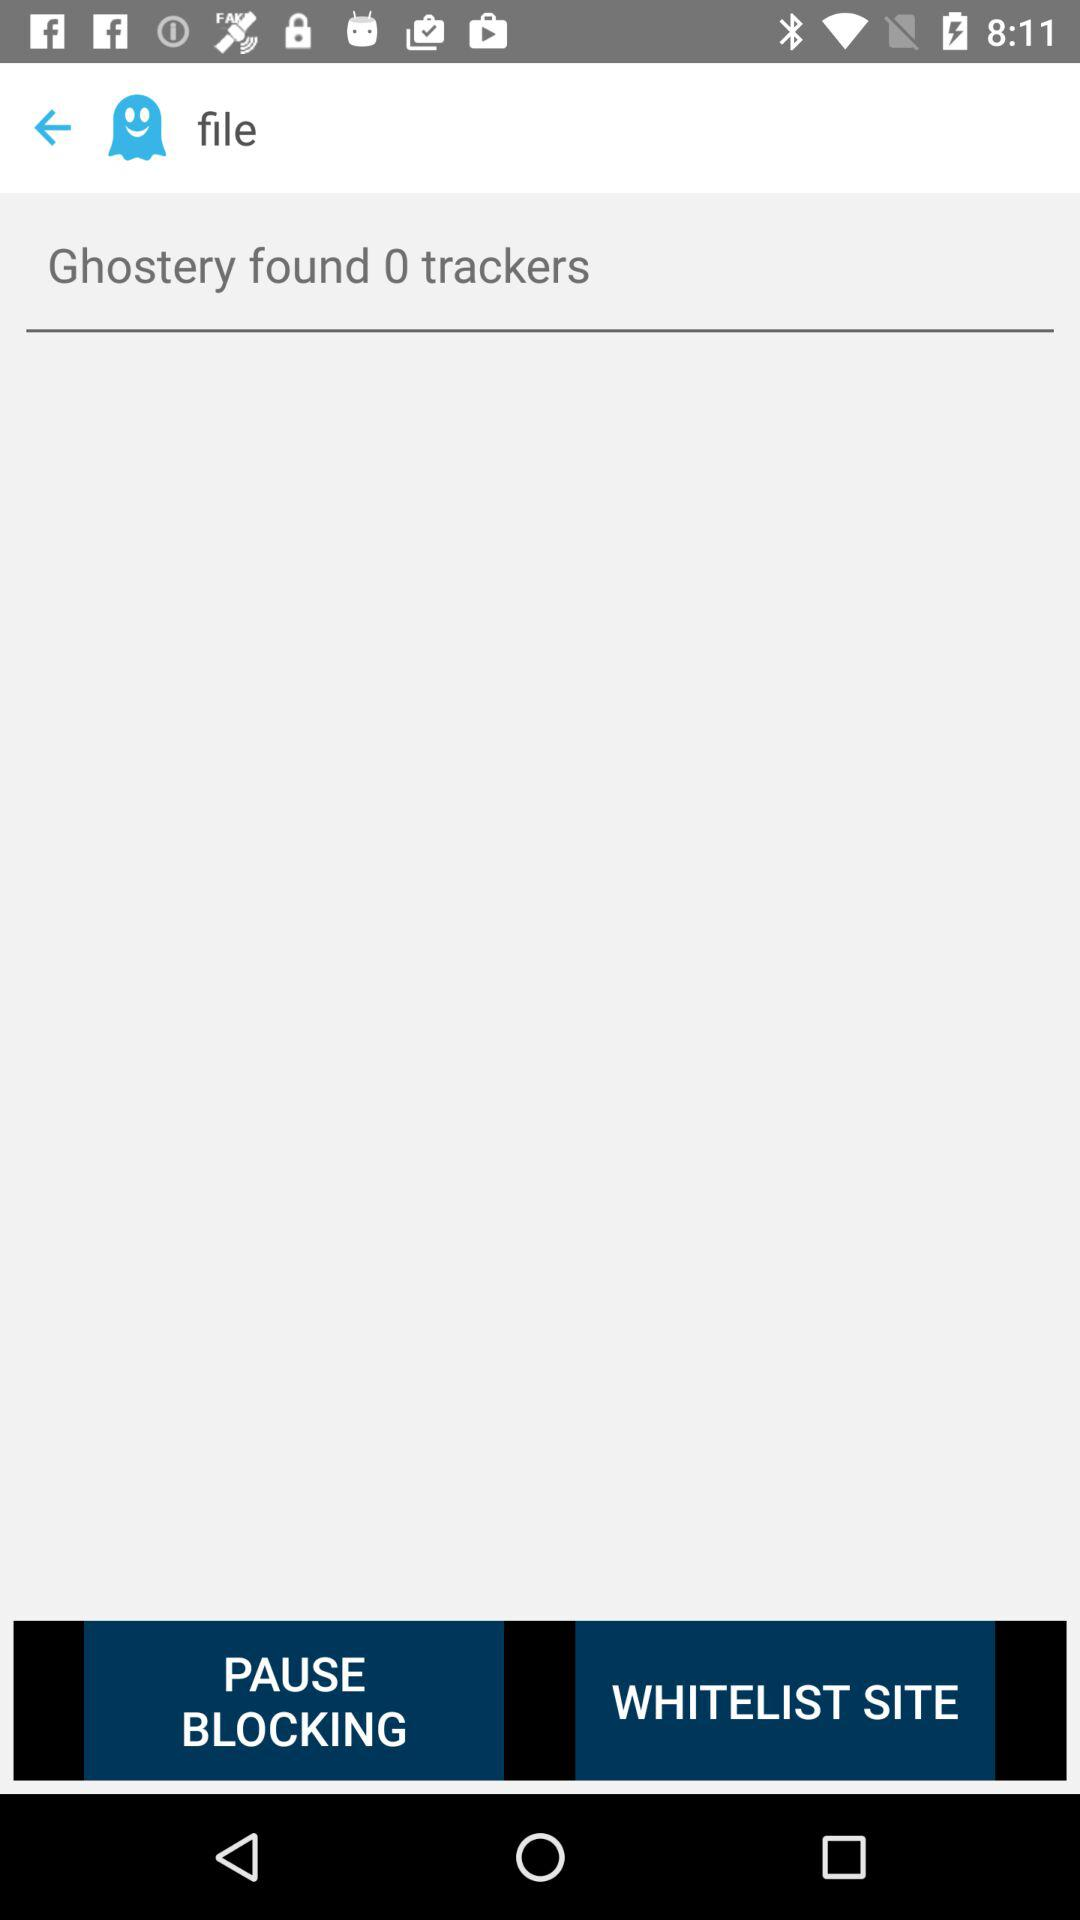How many followers are there?
When the provided information is insufficient, respond with <no answer>. <no answer> 